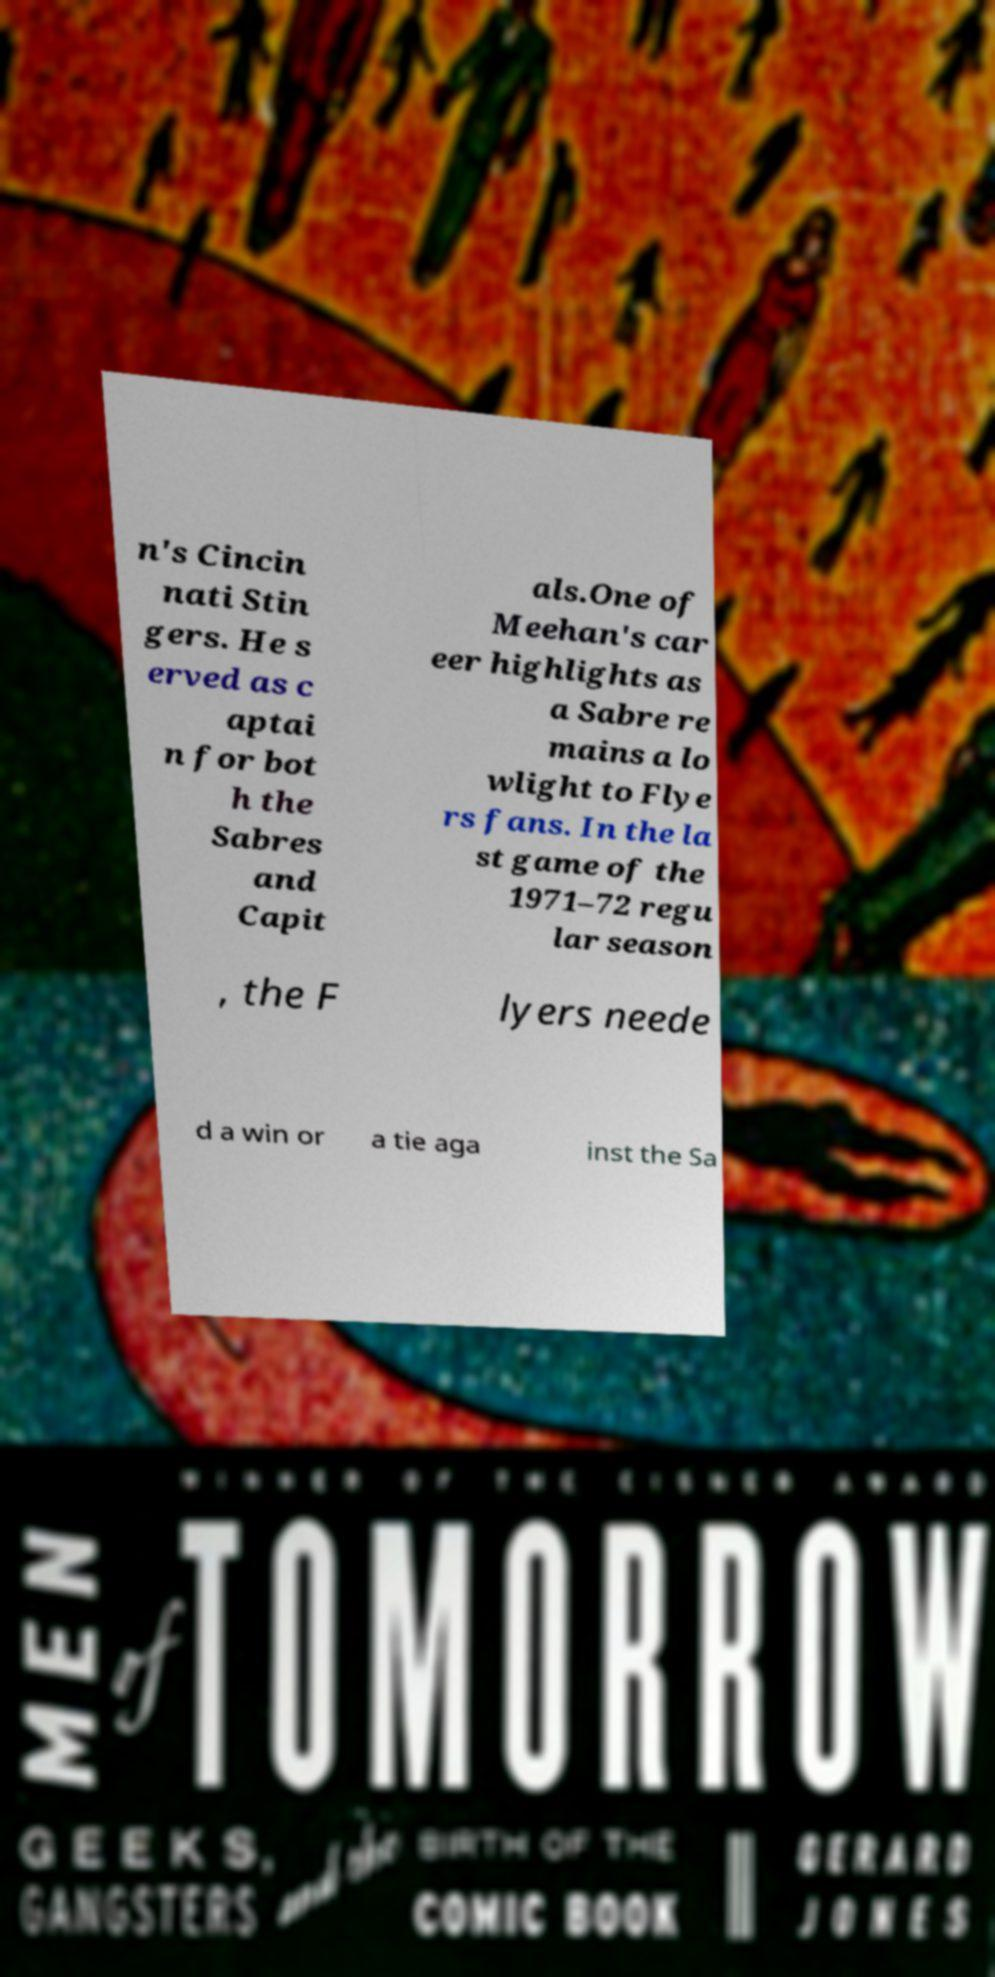What messages or text are displayed in this image? I need them in a readable, typed format. n's Cincin nati Stin gers. He s erved as c aptai n for bot h the Sabres and Capit als.One of Meehan's car eer highlights as a Sabre re mains a lo wlight to Flye rs fans. In the la st game of the 1971–72 regu lar season , the F lyers neede d a win or a tie aga inst the Sa 